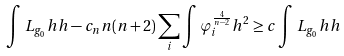Convert formula to latex. <formula><loc_0><loc_0><loc_500><loc_500>\int L _ { g _ { 0 } } h h - c _ { n } n ( n + 2 ) \sum _ { i } \int \varphi _ { i } ^ { \frac { 4 } { n - 2 } } h ^ { 2 } \geq c \int L _ { g _ { 0 } } h h</formula> 